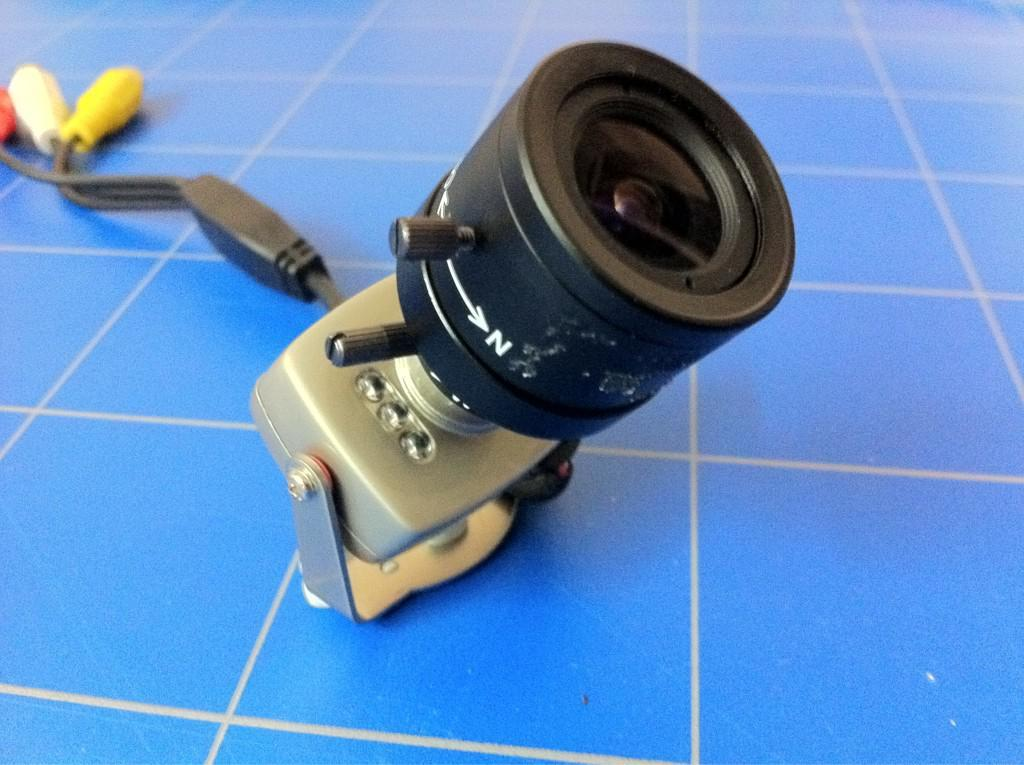What is the main object in the image? There is a camera in the image. What is the color of the floor where the camera is placed? The camera is on a blue color floor. What other items can be seen in the image besides the camera? There are red, white, and yellow color pins in the image. What type of jelly is being used to hold the camera in place in the image? There is no jelly present in the image, and the camera is not being held in place by any jelly. 